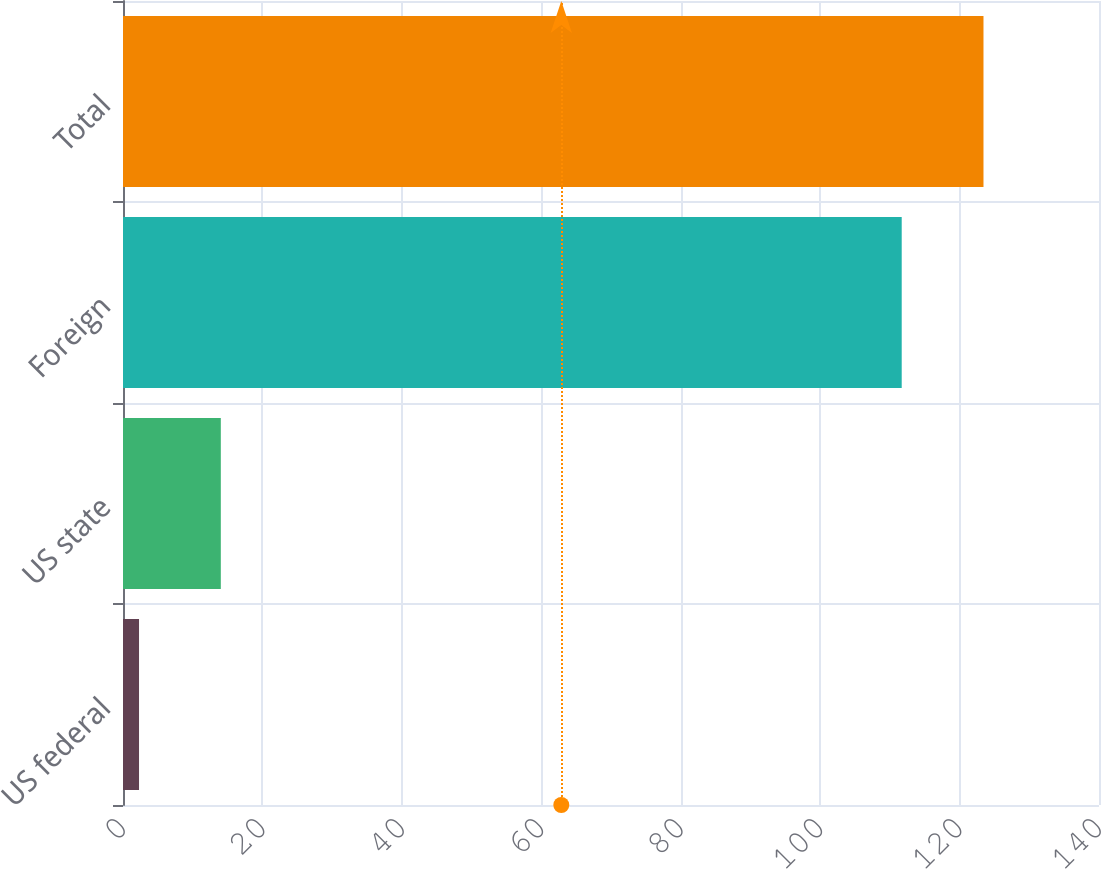Convert chart. <chart><loc_0><loc_0><loc_500><loc_500><bar_chart><fcel>US federal<fcel>US state<fcel>Foreign<fcel>Total<nl><fcel>2.3<fcel>14.03<fcel>111.7<fcel>123.43<nl></chart> 